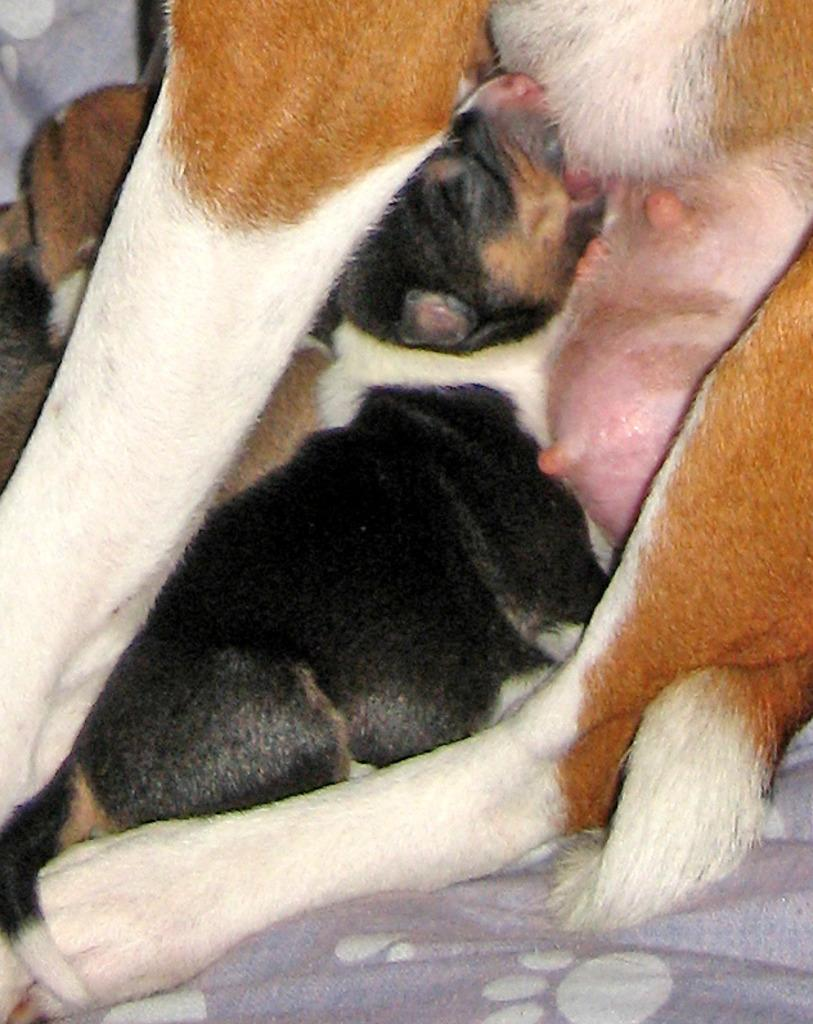What type of animal is present in the image? There is a dog and a puppy in the image. Where is the puppy located? The puppy is on a bed. Can you describe the relationship between the dog and the puppy? The dog and the puppy are likely related, as they are both present in the image. How many oranges are on the bed with the puppy? There are no oranges present in the image; it only features a dog and a puppy on a bed. 